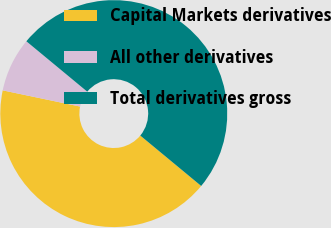Convert chart. <chart><loc_0><loc_0><loc_500><loc_500><pie_chart><fcel>Capital Markets derivatives<fcel>All other derivatives<fcel>Total derivatives gross<nl><fcel>42.28%<fcel>7.72%<fcel>50.0%<nl></chart> 